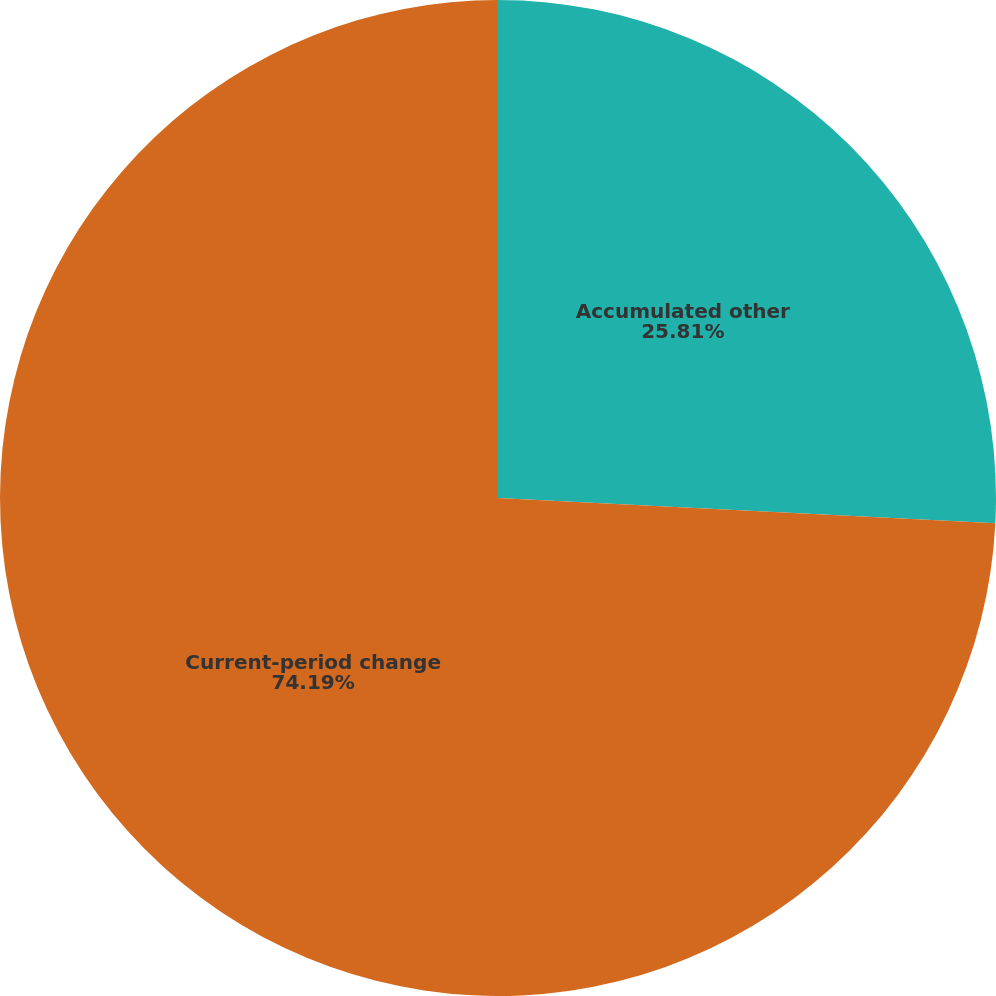<chart> <loc_0><loc_0><loc_500><loc_500><pie_chart><fcel>Accumulated other<fcel>Current-period change<nl><fcel>25.81%<fcel>74.19%<nl></chart> 